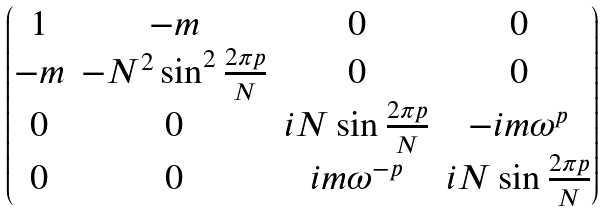<formula> <loc_0><loc_0><loc_500><loc_500>\begin{pmatrix} 1 & - m & 0 & 0 \\ - m & - N ^ { 2 } \sin ^ { 2 } \frac { 2 \pi p } { N } & 0 & 0 \\ 0 & 0 & i N \sin \frac { 2 \pi p } { N } & - i m \omega ^ { p } \\ 0 & 0 & i m \omega ^ { - p } & i N \sin \frac { 2 \pi p } { N } \end{pmatrix}</formula> 